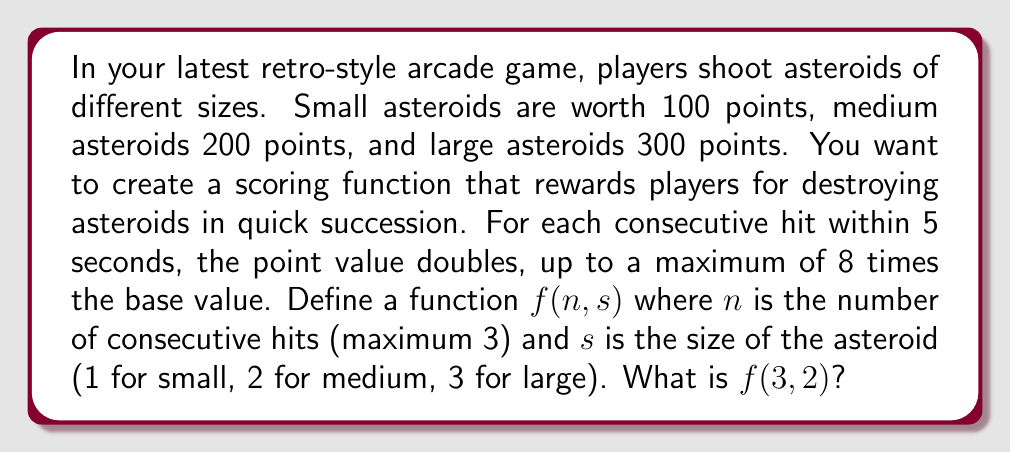What is the answer to this math problem? Let's approach this step-by-step:

1) First, we need to define the base scores for each asteroid size:
   Small (s=1): 100 points
   Medium (s=2): 200 points
   Large (s=3): 300 points

2) We can represent this as: $100s$ where $s$ is the size (1, 2, or 3)

3) Now, for consecutive hits, the score doubles each time, up to 8 times the base value. This can be represented as $2^{n-1}$ where $n$ is the number of consecutive hits (1, 2, or 3).

4) However, we need to cap this at 8 times the base value. We can use the min function for this:
   $$\min(2^{n-1}, 8)$$

5) Putting it all together, our function becomes:
   $$f(n,s) = 100s \cdot \min(2^{n-1}, 8)$$

6) Now, let's calculate $f(3,2)$:
   - $n = 3$ (3 consecutive hits)
   - $s = 2$ (medium asteroid)

7) Plugging these values into our function:
   $$f(3,2) = 100 \cdot 2 \cdot \min(2^{3-1}, 8)$$
   $$= 200 \cdot \min(2^2, 8)$$
   $$= 200 \cdot \min(4, 8)$$
   $$= 200 \cdot 4$$
   $$= 800$$

Therefore, $f(3,2) = 800$ points.
Answer: 800 